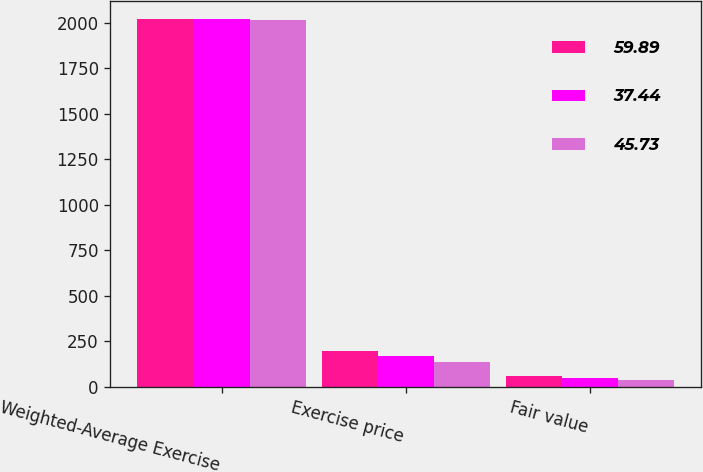<chart> <loc_0><loc_0><loc_500><loc_500><stacked_bar_chart><ecel><fcel>Weighted-Average Exercise<fcel>Exercise price<fcel>Fair value<nl><fcel>59.89<fcel>2018<fcel>196.78<fcel>59.89<nl><fcel>37.44<fcel>2017<fcel>170.24<fcel>45.73<nl><fcel>45.73<fcel>2016<fcel>135.02<fcel>37.44<nl></chart> 